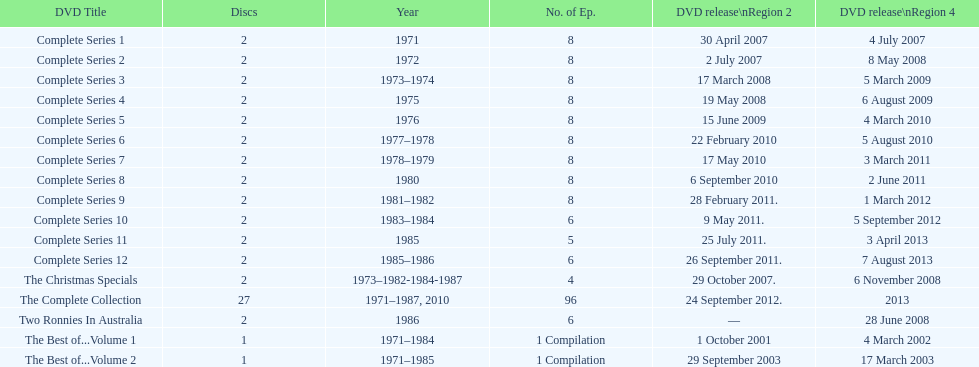How many series consisted of 8 episodes? 9. 